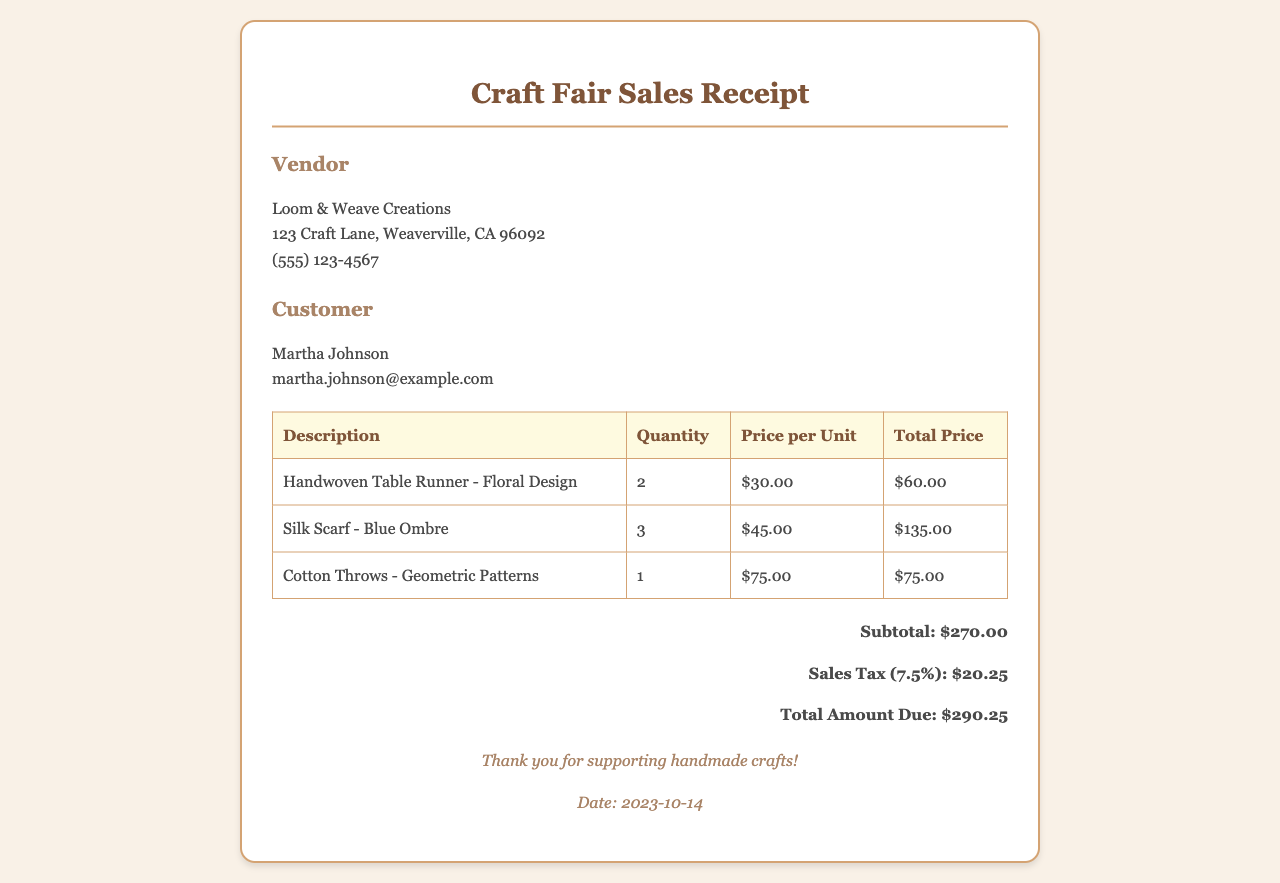What is the name of the vendor? The vendor's name is provided at the top of the receipt, which is Loom & Weave Creations.
Answer: Loom & Weave Creations How many Silk Scarves were sold? The quantity of Silk Scarves sold is listed in the table under the Quantity column for that item, which is 3.
Answer: 3 What is the price per unit of the Handwoven Table Runner? The price per unit for the Handwoven Table Runner is shown in the Price per Unit column, which is $30.00.
Answer: $30.00 What is the total amount due? The total amount due is calculated and presented at the bottom of the receipt, which is $290.25.
Answer: $290.25 What is the date of the transaction? The date of the transaction is provided in the footer section of the receipt, which is 2023-10-14.
Answer: 2023-10-14 How much sales tax was collected? The sales tax amount is listed separately in the total calculations, which is $20.25.
Answer: $20.25 What type of fabric is the Cotton Throw made of? The fabric type for the Cotton Throws is stated as Cotton, mentioned in the description of the item.
Answer: Cotton What is the subtotal before tax? The subtotal is specifically mentioned within the total calculations section at $270.00.
Answer: $270.00 How many different items were sold? The number of different items sold can be counted in the table, which lists 3 unique items.
Answer: 3 